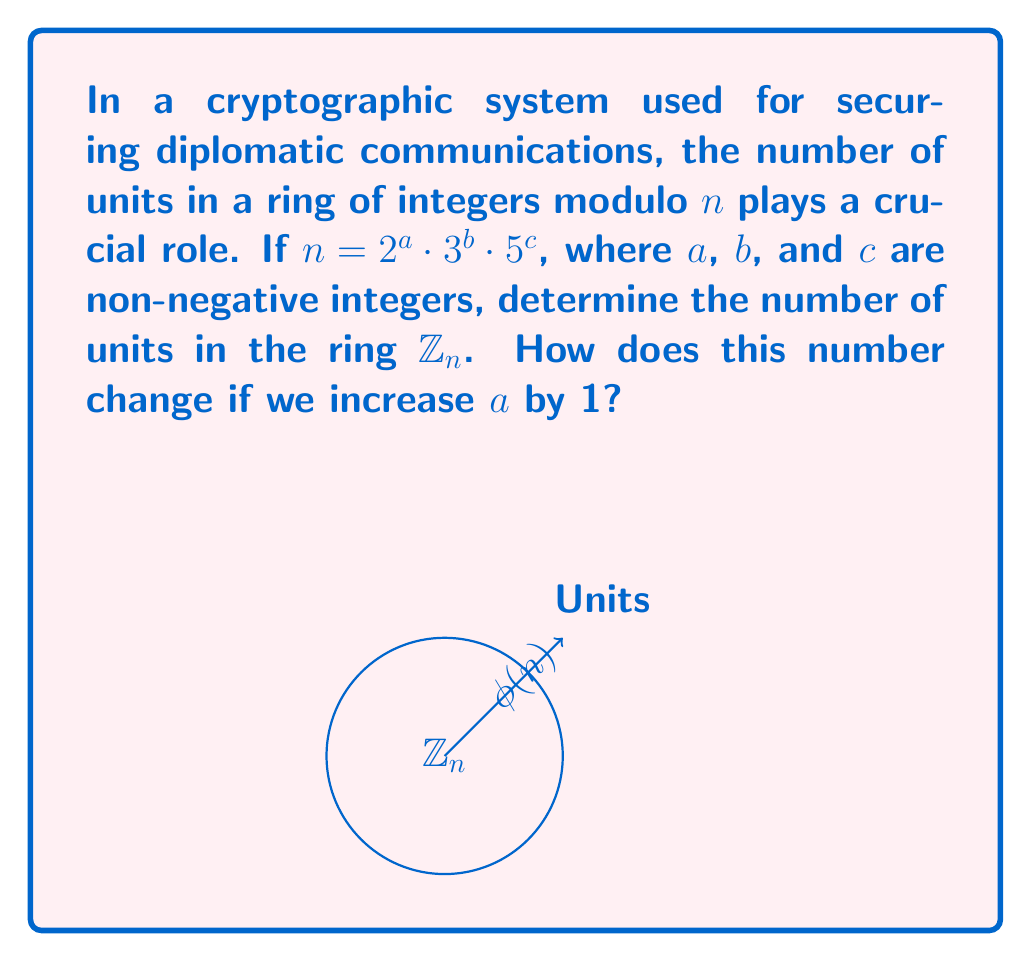Help me with this question. To solve this problem, we'll follow these steps:

1) First, recall that the number of units in $\mathbb{Z}_n$ is given by Euler's totient function $\phi(n)$.

2) For a prime power $p^k$, $\phi(p^k) = p^k - p^{k-1} = p^k(1-\frac{1}{p})$.

3) The Euler totient function is multiplicative, meaning for coprime numbers $a$ and $b$, $\phi(ab) = \phi(a)\phi(b)$.

4) Given $n = 2^a \cdot 3^b \cdot 5^c$, we can calculate $\phi(n)$ as:

   $$\phi(n) = \phi(2^a) \cdot \phi(3^b) \cdot \phi(5^c)$$

5) Substituting the formula from step 2:

   $$\phi(n) = 2^a(1-\frac{1}{2}) \cdot 3^b(1-\frac{1}{3}) \cdot 5^c(1-\frac{1}{5})$$

6) Simplifying:

   $$\phi(n) = 2^a \cdot \frac{1}{2} \cdot 3^b \cdot \frac{2}{3} \cdot 5^c \cdot \frac{4}{5}$$

   $$\phi(n) = 2^{a-1} \cdot 3^{b-1} \cdot 5^{c-1} \cdot 2 \cdot 2 \cdot 4$$

   $$\phi(n) = 2^{a+1} \cdot 3^{b-1} \cdot 5^{c-1} \cdot 4$$

7) If we increase $a$ by 1, the new number of units will be:

   $$\phi(n_{new}) = 2^{(a+1)+1} \cdot 3^{b-1} \cdot 5^{c-1} \cdot 4 = 2 \cdot \phi(n)$$

Thus, increasing $a$ by 1 doubles the number of units in the ring.
Answer: $\phi(n) = 2^{a+1} \cdot 3^{b-1} \cdot 5^{c-1} \cdot 4$; doubling when $a$ increases by 1. 